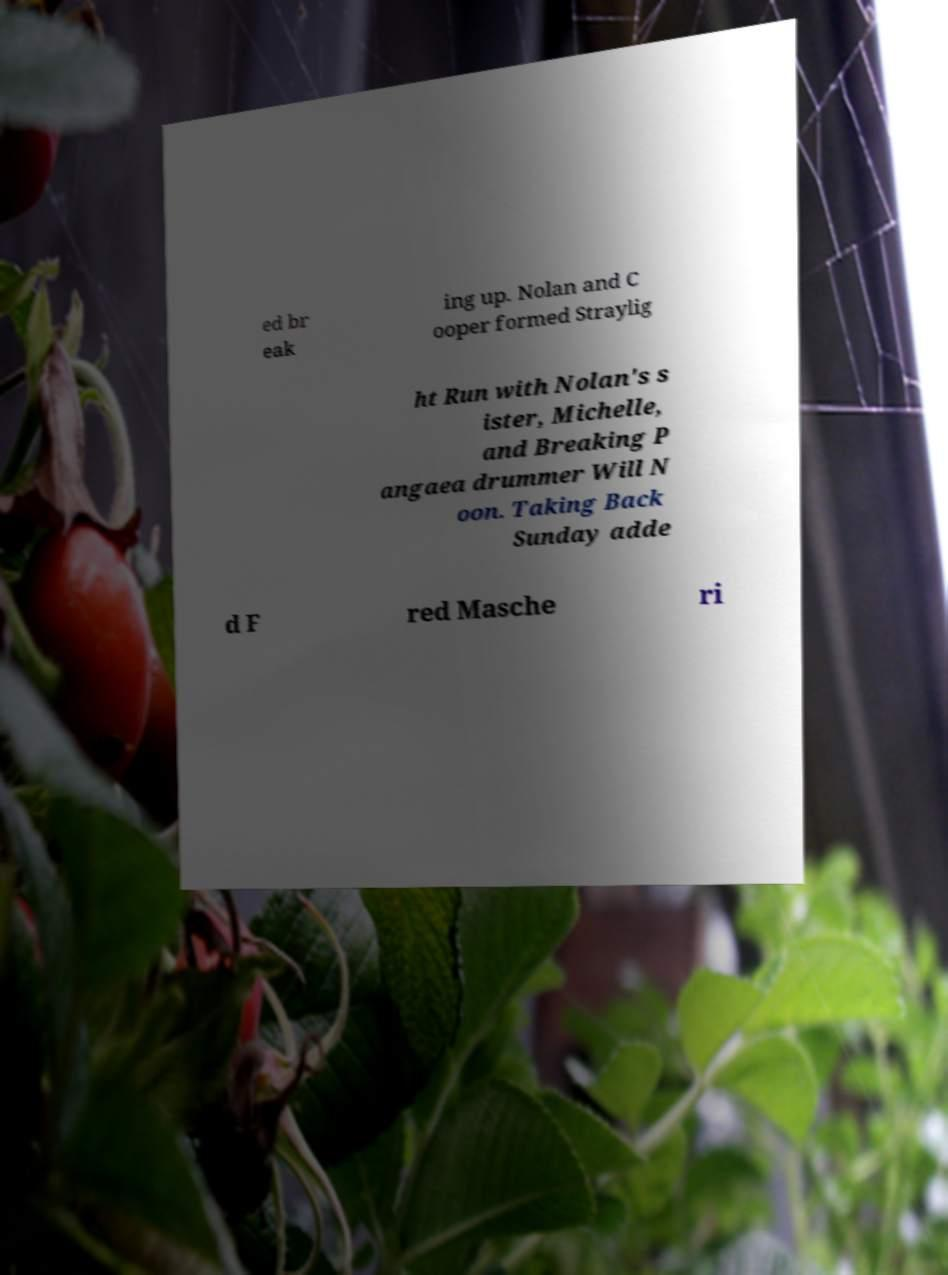There's text embedded in this image that I need extracted. Can you transcribe it verbatim? ed br eak ing up. Nolan and C ooper formed Straylig ht Run with Nolan's s ister, Michelle, and Breaking P angaea drummer Will N oon. Taking Back Sunday adde d F red Masche ri 